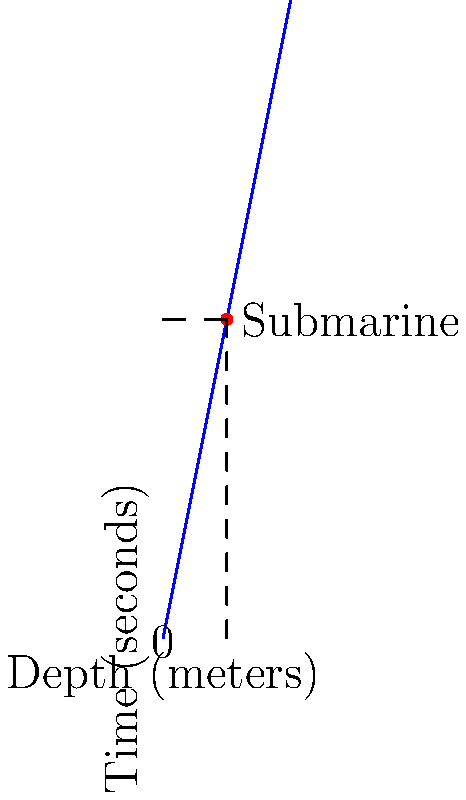Captain Nemo's submarine is diving deeper into the ocean. The depth gauge shows that for every 1 meter the submarine descends, it takes 5 seconds. If the submarine has been diving for 50 seconds, how deep is it now? Let's solve this step-by-step:

1. We know that for every 1 meter of depth, it takes 5 seconds.
2. We can write this as a ratio: 1 meter : 5 seconds
3. The submarine has been diving for 50 seconds.
4. To find the depth, we need to set up a proportion:
   
   $$\frac{1 \text{ meter}}{5 \text{ seconds}} = \frac{x \text{ meters}}{50 \text{ seconds}}$$

5. Cross multiply:
   
   $$1 \cdot 50 = 5x$$

6. Solve for x:
   
   $$50 = 5x$$
   $$x = 50 \div 5 = 10$$

Therefore, after 50 seconds, the submarine is 10 meters deep.
Answer: 10 meters 